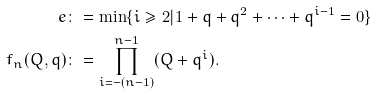<formula> <loc_0><loc_0><loc_500><loc_500>e & \colon = \min \{ i \geq 2 | 1 + q + q ^ { 2 } + \cdots + q ^ { i - 1 } = 0 \} \\ f _ { n } ( Q , q ) & \colon = \prod _ { i = - ( n - 1 ) } ^ { n - 1 } ( Q + q ^ { i } ) .</formula> 